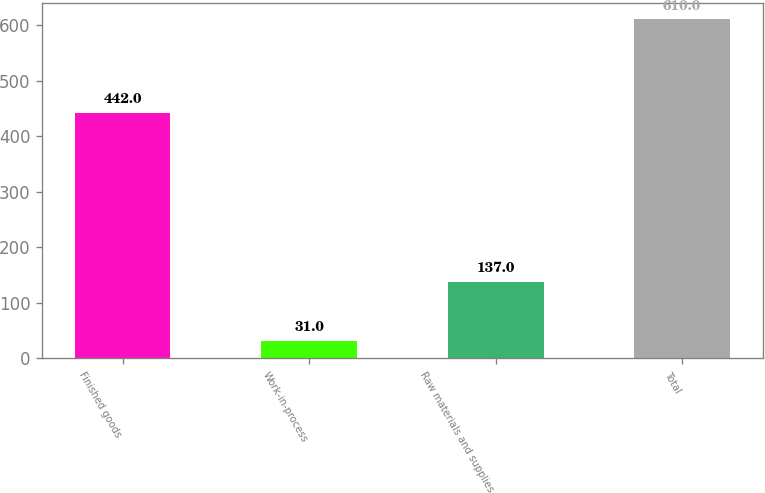Convert chart. <chart><loc_0><loc_0><loc_500><loc_500><bar_chart><fcel>Finished goods<fcel>Work-in-process<fcel>Raw materials and supplies<fcel>Total<nl><fcel>442<fcel>31<fcel>137<fcel>610<nl></chart> 